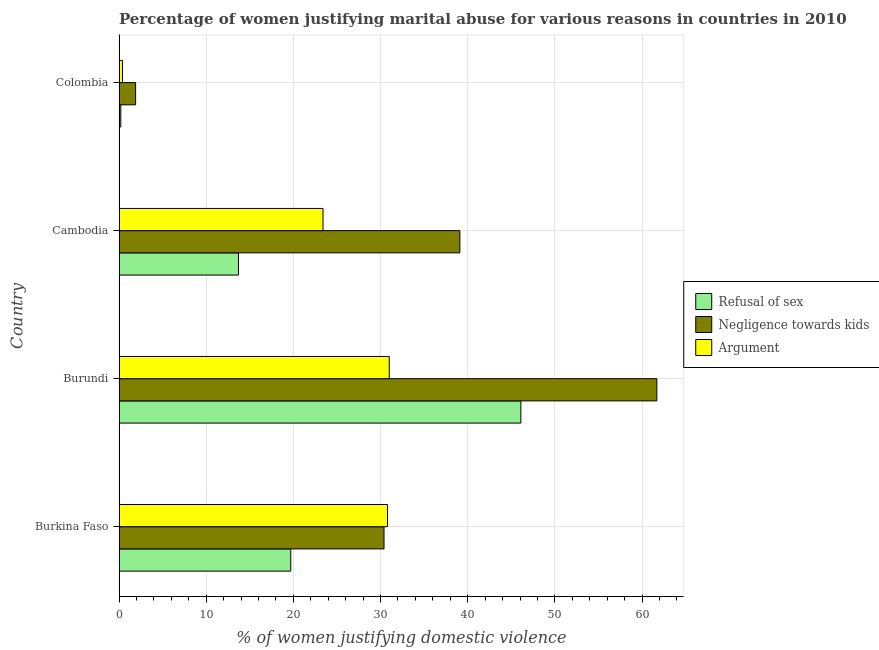How many different coloured bars are there?
Your answer should be compact. 3. Are the number of bars on each tick of the Y-axis equal?
Offer a terse response. Yes. How many bars are there on the 4th tick from the top?
Give a very brief answer. 3. How many bars are there on the 2nd tick from the bottom?
Provide a succinct answer. 3. In how many cases, is the number of bars for a given country not equal to the number of legend labels?
Offer a very short reply. 0. What is the percentage of women justifying domestic violence due to negligence towards kids in Colombia?
Provide a short and direct response. 1.9. Across all countries, what is the maximum percentage of women justifying domestic violence due to negligence towards kids?
Your answer should be very brief. 61.7. Across all countries, what is the minimum percentage of women justifying domestic violence due to refusal of sex?
Ensure brevity in your answer.  0.2. In which country was the percentage of women justifying domestic violence due to arguments maximum?
Keep it short and to the point. Burundi. In which country was the percentage of women justifying domestic violence due to arguments minimum?
Your response must be concise. Colombia. What is the total percentage of women justifying domestic violence due to arguments in the graph?
Give a very brief answer. 85.6. What is the difference between the percentage of women justifying domestic violence due to refusal of sex in Burundi and that in Cambodia?
Your answer should be compact. 32.4. What is the average percentage of women justifying domestic violence due to refusal of sex per country?
Provide a short and direct response. 19.93. What is the ratio of the percentage of women justifying domestic violence due to arguments in Burundi to that in Cambodia?
Give a very brief answer. 1.32. What is the difference between the highest and the second highest percentage of women justifying domestic violence due to refusal of sex?
Give a very brief answer. 26.4. What is the difference between the highest and the lowest percentage of women justifying domestic violence due to refusal of sex?
Give a very brief answer. 45.9. In how many countries, is the percentage of women justifying domestic violence due to refusal of sex greater than the average percentage of women justifying domestic violence due to refusal of sex taken over all countries?
Give a very brief answer. 1. Is the sum of the percentage of women justifying domestic violence due to negligence towards kids in Burundi and Cambodia greater than the maximum percentage of women justifying domestic violence due to refusal of sex across all countries?
Provide a short and direct response. Yes. What does the 2nd bar from the top in Colombia represents?
Provide a succinct answer. Negligence towards kids. What does the 3rd bar from the bottom in Colombia represents?
Offer a very short reply. Argument. How many countries are there in the graph?
Make the answer very short. 4. What is the difference between two consecutive major ticks on the X-axis?
Provide a succinct answer. 10. How are the legend labels stacked?
Your answer should be compact. Vertical. What is the title of the graph?
Provide a short and direct response. Percentage of women justifying marital abuse for various reasons in countries in 2010. Does "ICT services" appear as one of the legend labels in the graph?
Ensure brevity in your answer.  No. What is the label or title of the X-axis?
Provide a short and direct response. % of women justifying domestic violence. What is the label or title of the Y-axis?
Keep it short and to the point. Country. What is the % of women justifying domestic violence in Negligence towards kids in Burkina Faso?
Ensure brevity in your answer.  30.4. What is the % of women justifying domestic violence of Argument in Burkina Faso?
Provide a succinct answer. 30.8. What is the % of women justifying domestic violence of Refusal of sex in Burundi?
Make the answer very short. 46.1. What is the % of women justifying domestic violence of Negligence towards kids in Burundi?
Provide a succinct answer. 61.7. What is the % of women justifying domestic violence of Argument in Burundi?
Offer a terse response. 31. What is the % of women justifying domestic violence in Negligence towards kids in Cambodia?
Your answer should be very brief. 39.1. What is the % of women justifying domestic violence in Argument in Cambodia?
Provide a short and direct response. 23.4. What is the % of women justifying domestic violence in Negligence towards kids in Colombia?
Your answer should be compact. 1.9. Across all countries, what is the maximum % of women justifying domestic violence in Refusal of sex?
Ensure brevity in your answer.  46.1. Across all countries, what is the maximum % of women justifying domestic violence in Negligence towards kids?
Provide a short and direct response. 61.7. Across all countries, what is the maximum % of women justifying domestic violence of Argument?
Ensure brevity in your answer.  31. Across all countries, what is the minimum % of women justifying domestic violence of Negligence towards kids?
Offer a very short reply. 1.9. What is the total % of women justifying domestic violence of Refusal of sex in the graph?
Your answer should be very brief. 79.7. What is the total % of women justifying domestic violence of Negligence towards kids in the graph?
Give a very brief answer. 133.1. What is the total % of women justifying domestic violence of Argument in the graph?
Provide a short and direct response. 85.6. What is the difference between the % of women justifying domestic violence of Refusal of sex in Burkina Faso and that in Burundi?
Give a very brief answer. -26.4. What is the difference between the % of women justifying domestic violence in Negligence towards kids in Burkina Faso and that in Burundi?
Your response must be concise. -31.3. What is the difference between the % of women justifying domestic violence of Refusal of sex in Burkina Faso and that in Cambodia?
Make the answer very short. 6. What is the difference between the % of women justifying domestic violence in Negligence towards kids in Burkina Faso and that in Cambodia?
Provide a short and direct response. -8.7. What is the difference between the % of women justifying domestic violence of Argument in Burkina Faso and that in Cambodia?
Your answer should be very brief. 7.4. What is the difference between the % of women justifying domestic violence in Negligence towards kids in Burkina Faso and that in Colombia?
Your response must be concise. 28.5. What is the difference between the % of women justifying domestic violence of Argument in Burkina Faso and that in Colombia?
Give a very brief answer. 30.4. What is the difference between the % of women justifying domestic violence in Refusal of sex in Burundi and that in Cambodia?
Offer a terse response. 32.4. What is the difference between the % of women justifying domestic violence of Negligence towards kids in Burundi and that in Cambodia?
Provide a short and direct response. 22.6. What is the difference between the % of women justifying domestic violence in Refusal of sex in Burundi and that in Colombia?
Your response must be concise. 45.9. What is the difference between the % of women justifying domestic violence of Negligence towards kids in Burundi and that in Colombia?
Offer a terse response. 59.8. What is the difference between the % of women justifying domestic violence in Argument in Burundi and that in Colombia?
Ensure brevity in your answer.  30.6. What is the difference between the % of women justifying domestic violence of Refusal of sex in Cambodia and that in Colombia?
Your answer should be compact. 13.5. What is the difference between the % of women justifying domestic violence of Negligence towards kids in Cambodia and that in Colombia?
Your answer should be very brief. 37.2. What is the difference between the % of women justifying domestic violence in Argument in Cambodia and that in Colombia?
Your answer should be compact. 23. What is the difference between the % of women justifying domestic violence of Refusal of sex in Burkina Faso and the % of women justifying domestic violence of Negligence towards kids in Burundi?
Offer a terse response. -42. What is the difference between the % of women justifying domestic violence in Negligence towards kids in Burkina Faso and the % of women justifying domestic violence in Argument in Burundi?
Make the answer very short. -0.6. What is the difference between the % of women justifying domestic violence in Refusal of sex in Burkina Faso and the % of women justifying domestic violence in Negligence towards kids in Cambodia?
Your answer should be compact. -19.4. What is the difference between the % of women justifying domestic violence in Refusal of sex in Burkina Faso and the % of women justifying domestic violence in Argument in Cambodia?
Provide a short and direct response. -3.7. What is the difference between the % of women justifying domestic violence of Negligence towards kids in Burkina Faso and the % of women justifying domestic violence of Argument in Cambodia?
Ensure brevity in your answer.  7. What is the difference between the % of women justifying domestic violence in Refusal of sex in Burkina Faso and the % of women justifying domestic violence in Argument in Colombia?
Your response must be concise. 19.3. What is the difference between the % of women justifying domestic violence in Negligence towards kids in Burkina Faso and the % of women justifying domestic violence in Argument in Colombia?
Keep it short and to the point. 30. What is the difference between the % of women justifying domestic violence of Refusal of sex in Burundi and the % of women justifying domestic violence of Argument in Cambodia?
Your response must be concise. 22.7. What is the difference between the % of women justifying domestic violence of Negligence towards kids in Burundi and the % of women justifying domestic violence of Argument in Cambodia?
Make the answer very short. 38.3. What is the difference between the % of women justifying domestic violence of Refusal of sex in Burundi and the % of women justifying domestic violence of Negligence towards kids in Colombia?
Make the answer very short. 44.2. What is the difference between the % of women justifying domestic violence in Refusal of sex in Burundi and the % of women justifying domestic violence in Argument in Colombia?
Give a very brief answer. 45.7. What is the difference between the % of women justifying domestic violence of Negligence towards kids in Burundi and the % of women justifying domestic violence of Argument in Colombia?
Ensure brevity in your answer.  61.3. What is the difference between the % of women justifying domestic violence of Refusal of sex in Cambodia and the % of women justifying domestic violence of Negligence towards kids in Colombia?
Your answer should be very brief. 11.8. What is the difference between the % of women justifying domestic violence of Refusal of sex in Cambodia and the % of women justifying domestic violence of Argument in Colombia?
Your answer should be compact. 13.3. What is the difference between the % of women justifying domestic violence of Negligence towards kids in Cambodia and the % of women justifying domestic violence of Argument in Colombia?
Provide a short and direct response. 38.7. What is the average % of women justifying domestic violence of Refusal of sex per country?
Your answer should be compact. 19.93. What is the average % of women justifying domestic violence in Negligence towards kids per country?
Offer a very short reply. 33.27. What is the average % of women justifying domestic violence in Argument per country?
Provide a short and direct response. 21.4. What is the difference between the % of women justifying domestic violence in Refusal of sex and % of women justifying domestic violence in Argument in Burkina Faso?
Give a very brief answer. -11.1. What is the difference between the % of women justifying domestic violence in Refusal of sex and % of women justifying domestic violence in Negligence towards kids in Burundi?
Offer a terse response. -15.6. What is the difference between the % of women justifying domestic violence in Refusal of sex and % of women justifying domestic violence in Argument in Burundi?
Provide a short and direct response. 15.1. What is the difference between the % of women justifying domestic violence of Negligence towards kids and % of women justifying domestic violence of Argument in Burundi?
Ensure brevity in your answer.  30.7. What is the difference between the % of women justifying domestic violence in Refusal of sex and % of women justifying domestic violence in Negligence towards kids in Cambodia?
Ensure brevity in your answer.  -25.4. What is the difference between the % of women justifying domestic violence in Refusal of sex and % of women justifying domestic violence in Negligence towards kids in Colombia?
Provide a succinct answer. -1.7. What is the difference between the % of women justifying domestic violence in Refusal of sex and % of women justifying domestic violence in Argument in Colombia?
Make the answer very short. -0.2. What is the difference between the % of women justifying domestic violence in Negligence towards kids and % of women justifying domestic violence in Argument in Colombia?
Keep it short and to the point. 1.5. What is the ratio of the % of women justifying domestic violence of Refusal of sex in Burkina Faso to that in Burundi?
Provide a succinct answer. 0.43. What is the ratio of the % of women justifying domestic violence in Negligence towards kids in Burkina Faso to that in Burundi?
Offer a terse response. 0.49. What is the ratio of the % of women justifying domestic violence of Refusal of sex in Burkina Faso to that in Cambodia?
Give a very brief answer. 1.44. What is the ratio of the % of women justifying domestic violence in Negligence towards kids in Burkina Faso to that in Cambodia?
Your answer should be very brief. 0.78. What is the ratio of the % of women justifying domestic violence in Argument in Burkina Faso to that in Cambodia?
Provide a succinct answer. 1.32. What is the ratio of the % of women justifying domestic violence of Refusal of sex in Burkina Faso to that in Colombia?
Your answer should be compact. 98.5. What is the ratio of the % of women justifying domestic violence of Negligence towards kids in Burkina Faso to that in Colombia?
Offer a very short reply. 16. What is the ratio of the % of women justifying domestic violence of Refusal of sex in Burundi to that in Cambodia?
Offer a very short reply. 3.37. What is the ratio of the % of women justifying domestic violence of Negligence towards kids in Burundi to that in Cambodia?
Your answer should be compact. 1.58. What is the ratio of the % of women justifying domestic violence in Argument in Burundi to that in Cambodia?
Keep it short and to the point. 1.32. What is the ratio of the % of women justifying domestic violence in Refusal of sex in Burundi to that in Colombia?
Your answer should be compact. 230.5. What is the ratio of the % of women justifying domestic violence of Negligence towards kids in Burundi to that in Colombia?
Ensure brevity in your answer.  32.47. What is the ratio of the % of women justifying domestic violence of Argument in Burundi to that in Colombia?
Provide a succinct answer. 77.5. What is the ratio of the % of women justifying domestic violence of Refusal of sex in Cambodia to that in Colombia?
Keep it short and to the point. 68.5. What is the ratio of the % of women justifying domestic violence in Negligence towards kids in Cambodia to that in Colombia?
Provide a succinct answer. 20.58. What is the ratio of the % of women justifying domestic violence in Argument in Cambodia to that in Colombia?
Your answer should be compact. 58.5. What is the difference between the highest and the second highest % of women justifying domestic violence in Refusal of sex?
Provide a short and direct response. 26.4. What is the difference between the highest and the second highest % of women justifying domestic violence of Negligence towards kids?
Offer a terse response. 22.6. What is the difference between the highest and the lowest % of women justifying domestic violence of Refusal of sex?
Provide a short and direct response. 45.9. What is the difference between the highest and the lowest % of women justifying domestic violence of Negligence towards kids?
Give a very brief answer. 59.8. What is the difference between the highest and the lowest % of women justifying domestic violence of Argument?
Keep it short and to the point. 30.6. 